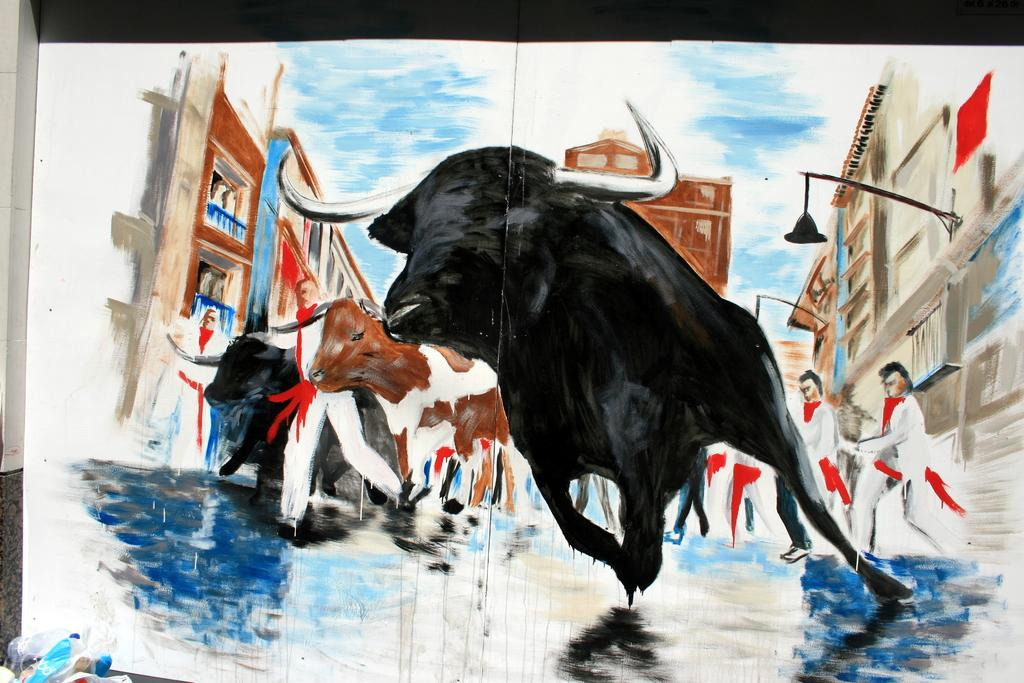What is the main subject of the image? The image contains a painting. What types of subjects are depicted in the painting? The painting depicts animals, persons, buildings, and the sky. What type of rice can be seen in the painting? There is no rice present in the painting; it depicts animals, persons, buildings, and the sky. How many sheep are visible in the painting? There are no sheep depicted in the painting; it features animals, persons, buildings, and the sky. 